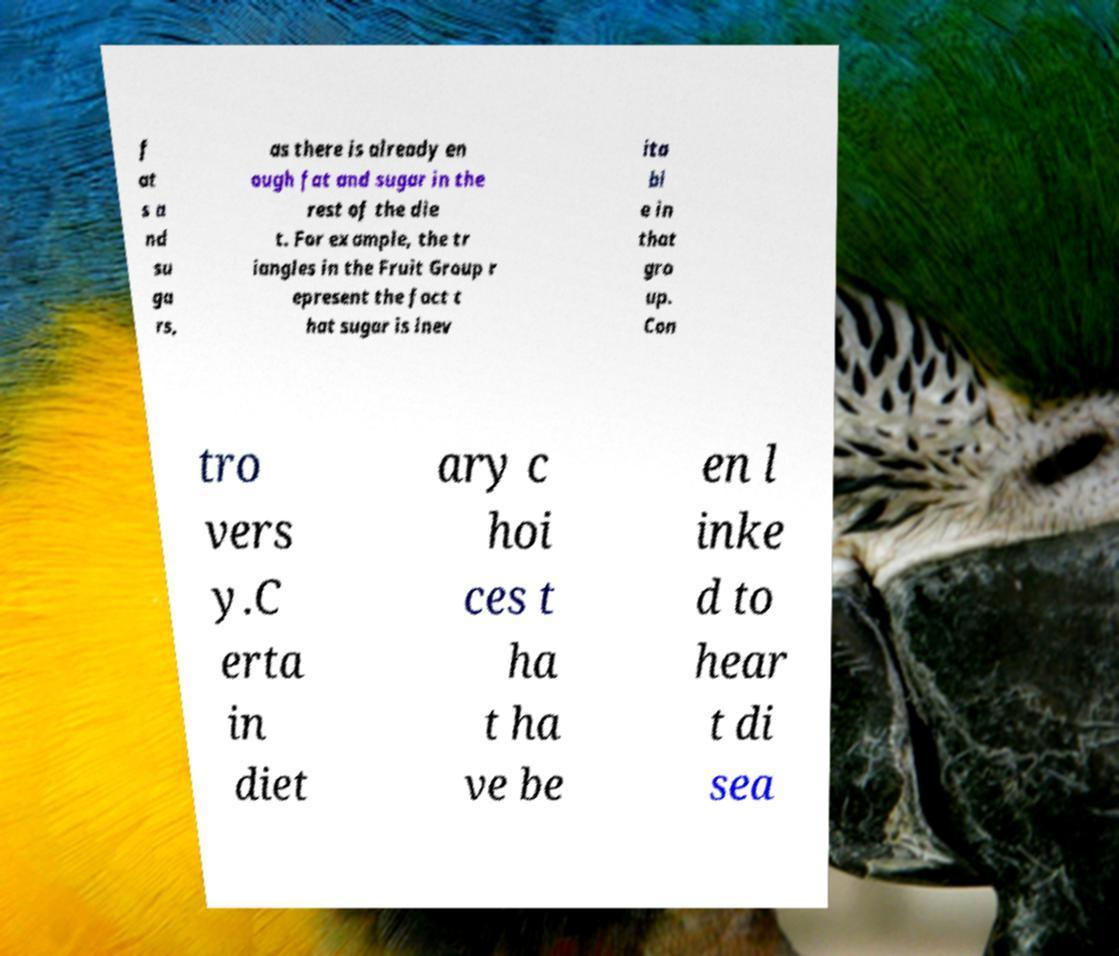Please identify and transcribe the text found in this image. f at s a nd su ga rs, as there is already en ough fat and sugar in the rest of the die t. For example, the tr iangles in the Fruit Group r epresent the fact t hat sugar is inev ita bl e in that gro up. Con tro vers y.C erta in diet ary c hoi ces t ha t ha ve be en l inke d to hear t di sea 